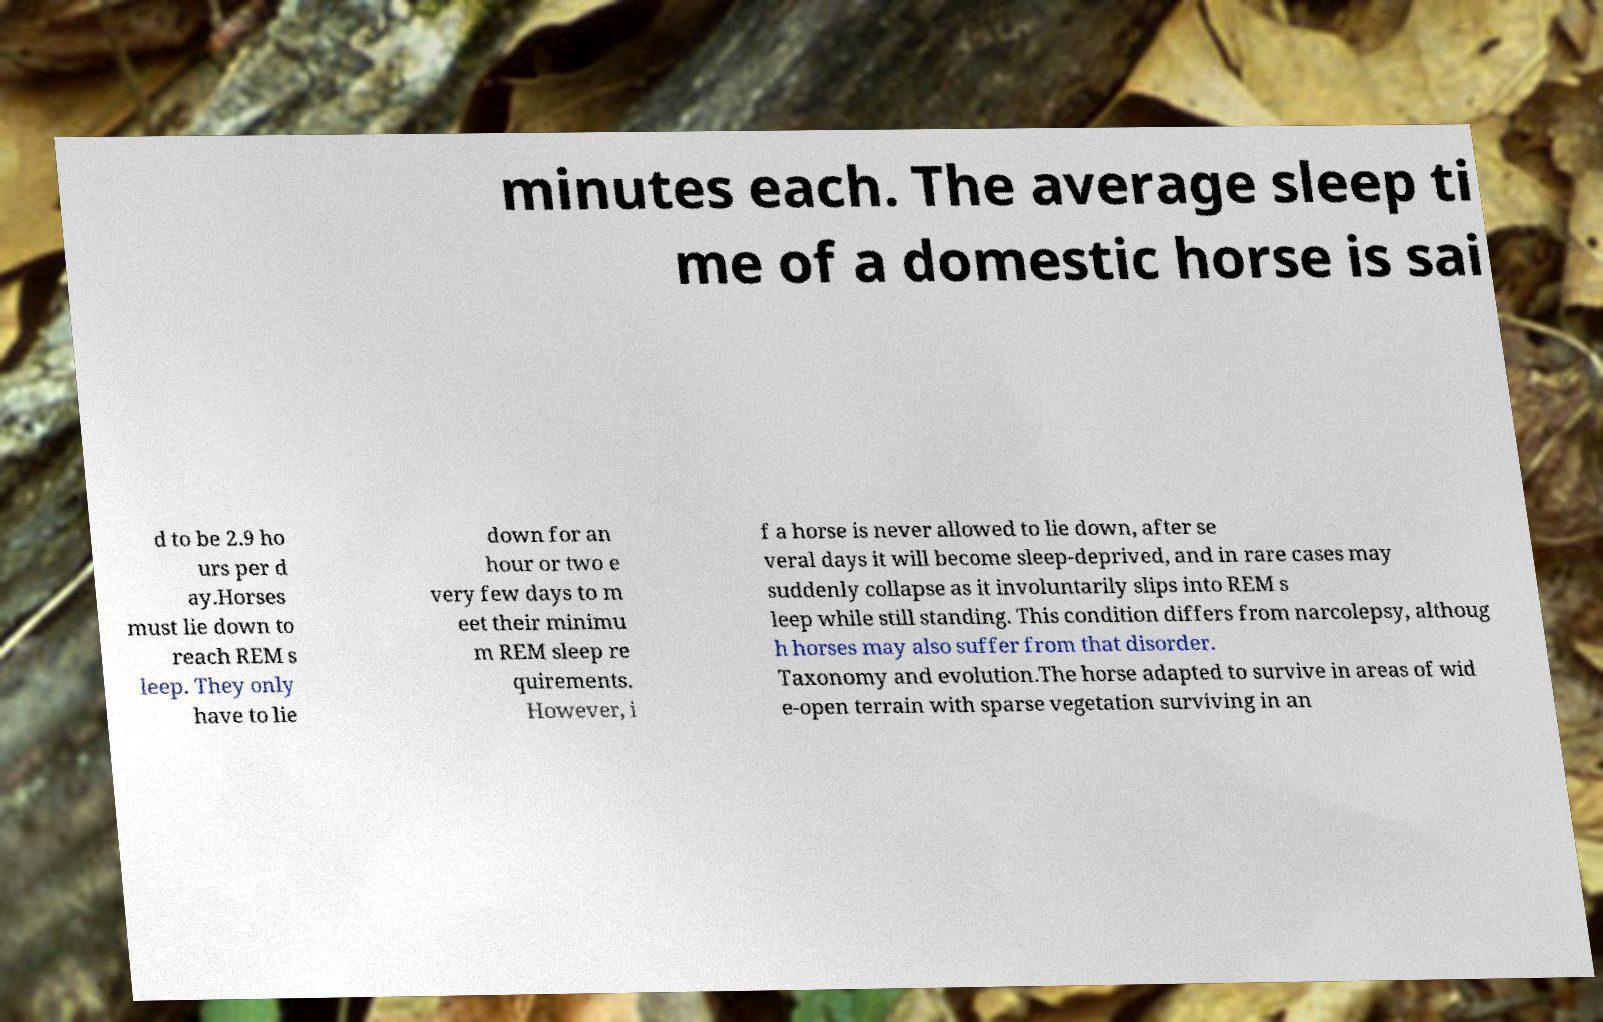There's text embedded in this image that I need extracted. Can you transcribe it verbatim? minutes each. The average sleep ti me of a domestic horse is sai d to be 2.9 ho urs per d ay.Horses must lie down to reach REM s leep. They only have to lie down for an hour or two e very few days to m eet their minimu m REM sleep re quirements. However, i f a horse is never allowed to lie down, after se veral days it will become sleep-deprived, and in rare cases may suddenly collapse as it involuntarily slips into REM s leep while still standing. This condition differs from narcolepsy, althoug h horses may also suffer from that disorder. Taxonomy and evolution.The horse adapted to survive in areas of wid e-open terrain with sparse vegetation surviving in an 